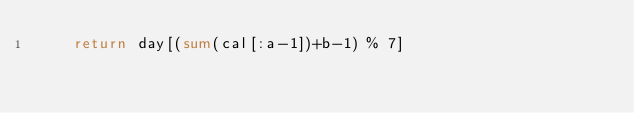Convert code to text. <code><loc_0><loc_0><loc_500><loc_500><_Python_>    return day[(sum(cal[:a-1])+b-1) % 7]</code> 